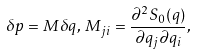<formula> <loc_0><loc_0><loc_500><loc_500>\delta { p } = { M } \delta { q } , \, { M } _ { j i } = \frac { \partial ^ { 2 } S _ { 0 } ( q ) } { \partial q _ { j } \partial q _ { i } } ,</formula> 